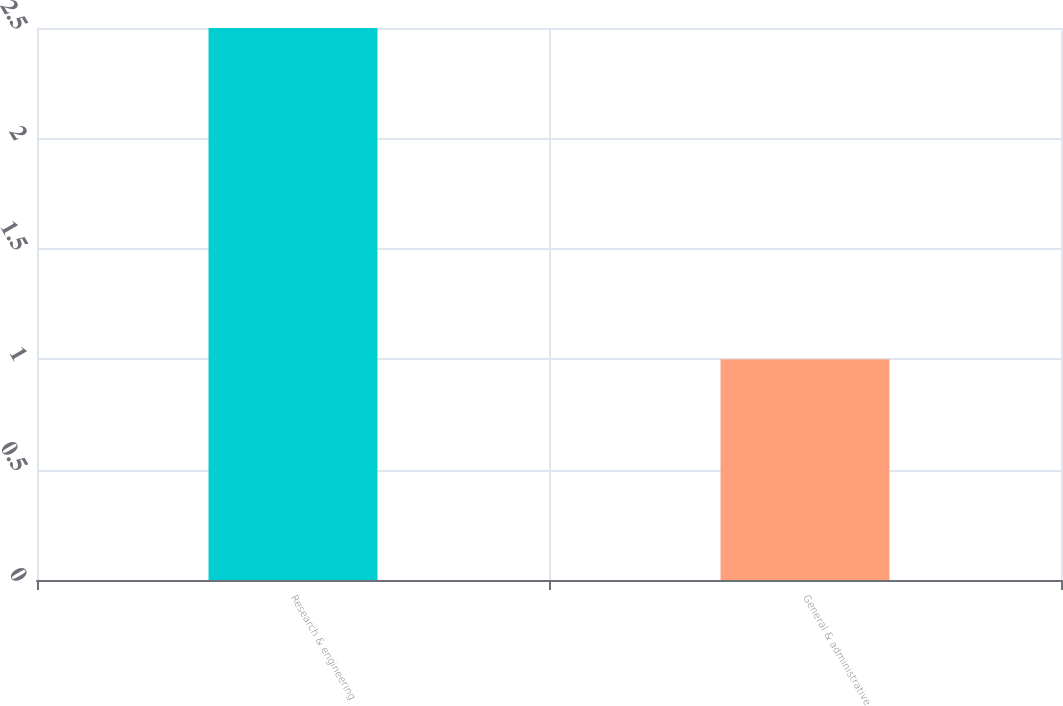<chart> <loc_0><loc_0><loc_500><loc_500><bar_chart><fcel>Research & engineering<fcel>General & administrative<nl><fcel>2.5<fcel>1<nl></chart> 